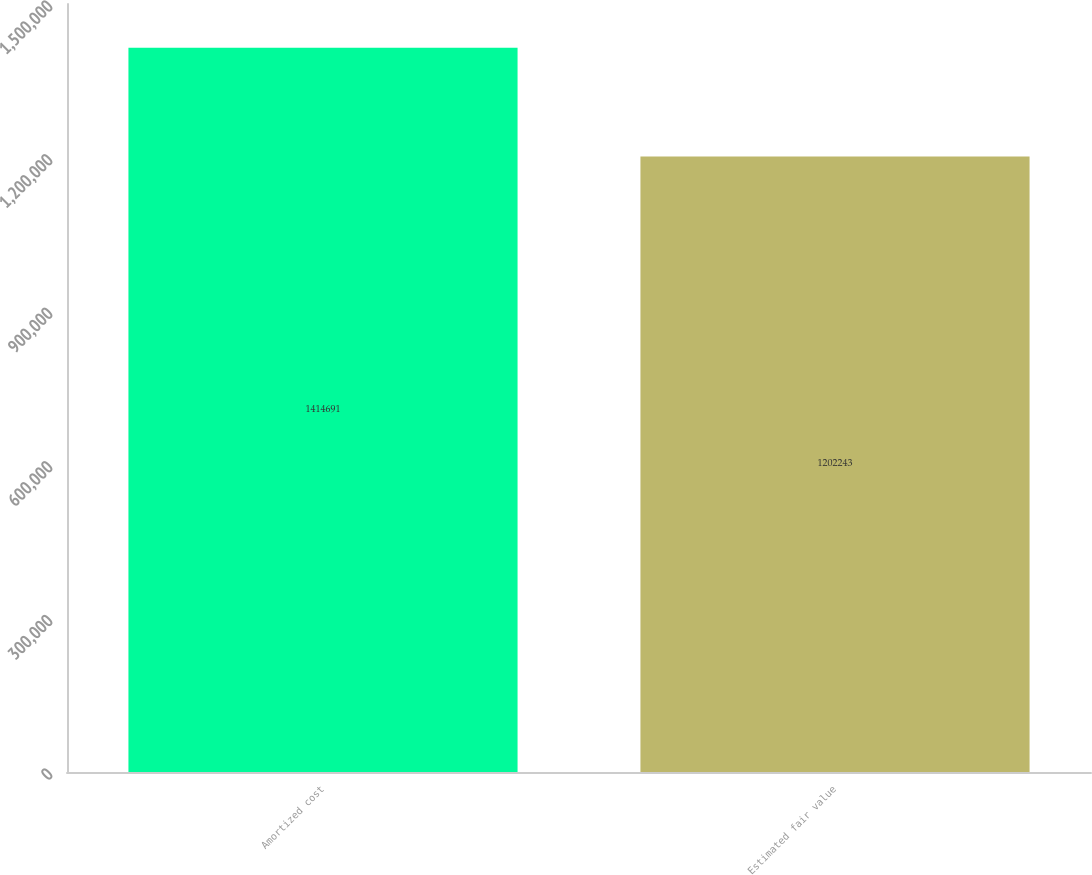Convert chart to OTSL. <chart><loc_0><loc_0><loc_500><loc_500><bar_chart><fcel>Amortized cost<fcel>Estimated fair value<nl><fcel>1.41469e+06<fcel>1.20224e+06<nl></chart> 